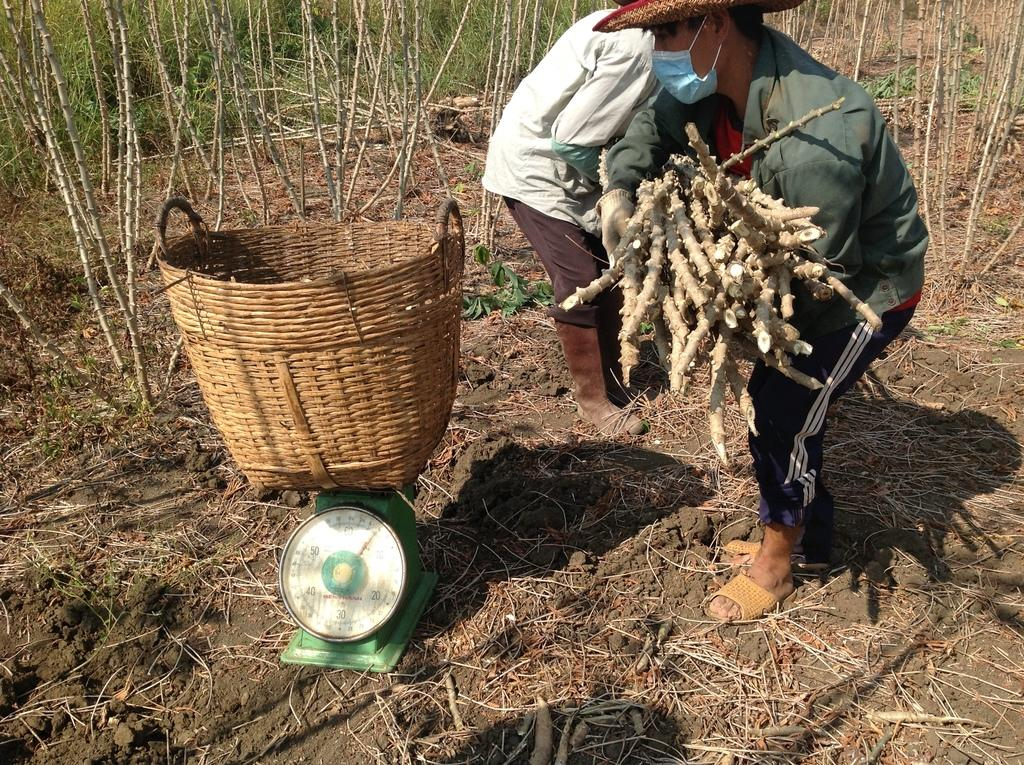What are the men holding in the image? The men are holding sticks in the image. What object is placed on a weighing machine in the image? There is a basket on a weighing machine in the image. What type of vegetation can be seen in the image? Plants are visible in the image. Can you describe the attire of one of the men in the image? There is a man wearing a hat in the image. What protective gear is one of the men wearing in the image? There is a man wearing a mask on his face in the image. What type of ship can be seen sailing in the image? There is no ship present in the image; it features men holding sticks, a basket on a weighing machine, plants, and men wearing hats and masks. What is the governor doing in the image? There is no governor present in the image. 